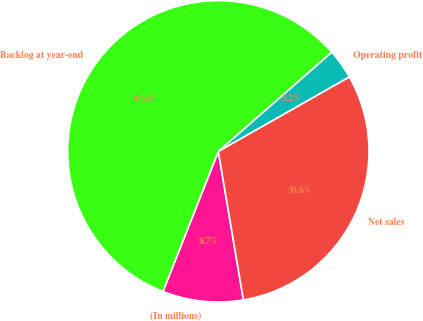<chart> <loc_0><loc_0><loc_500><loc_500><pie_chart><fcel>(In millions)<fcel>Net sales<fcel>Operating profit<fcel>Backlog at year-end<nl><fcel>8.65%<fcel>30.56%<fcel>3.21%<fcel>57.57%<nl></chart> 